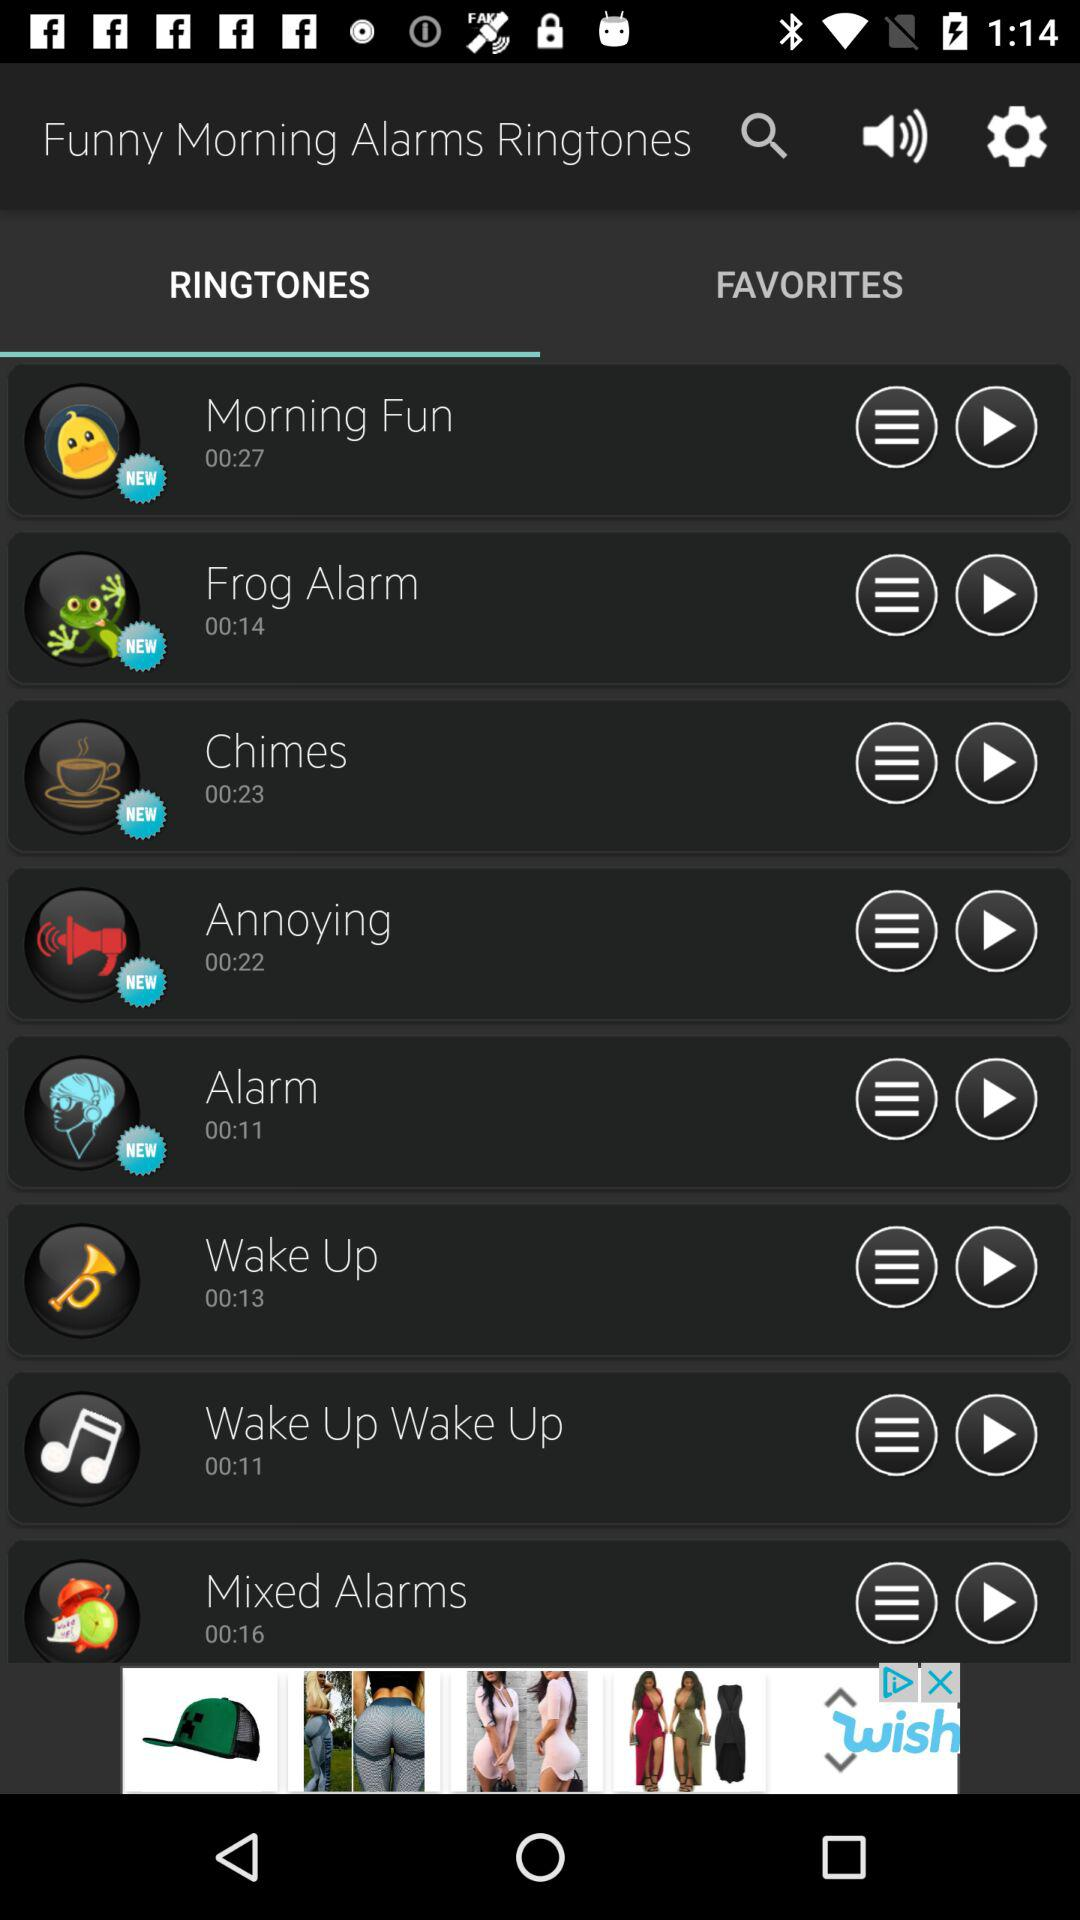What is the duration of the "Annoying" ringtone? The duration is 22 seconds. 